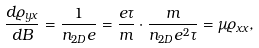<formula> <loc_0><loc_0><loc_500><loc_500>\frac { d \varrho _ { y x } } { d B } = \frac { 1 } { n _ { 2 D } e } = \frac { e \tau } { m } \cdot \frac { m } { n _ { 2 D } e ^ { 2 } \tau } = \mu \varrho _ { x x } ,</formula> 